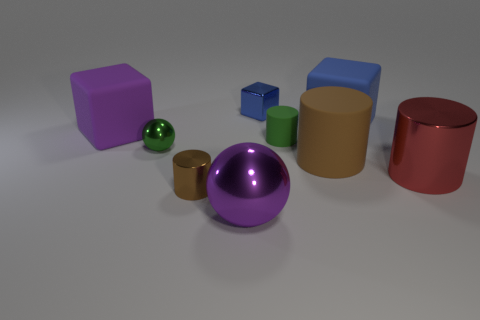Do the big cube to the left of the tiny blue metallic block and the big metallic thing that is on the left side of the large blue block have the same color?
Keep it short and to the point. Yes. Is there any other thing that is the same color as the big rubber cylinder?
Ensure brevity in your answer.  Yes. There is a cylinder that is right of the blue block right of the tiny matte cylinder; are there any red cylinders that are to the right of it?
Keep it short and to the point. No. Does the rubber block that is on the right side of the large purple metal sphere have the same color as the tiny ball?
Provide a succinct answer. No. How many cubes are gray matte things or large red things?
Offer a terse response. 0. What is the shape of the green object to the left of the metallic cylinder that is to the left of the red metal cylinder?
Make the answer very short. Sphere. There is a cylinder that is left of the purple object that is in front of the small object in front of the small ball; what is its size?
Offer a very short reply. Small. Does the blue matte block have the same size as the blue shiny block?
Your answer should be compact. No. What number of things are big red cylinders or shiny cylinders?
Offer a very short reply. 2. There is a blue thing right of the brown thing that is behind the red cylinder; how big is it?
Your response must be concise. Large. 